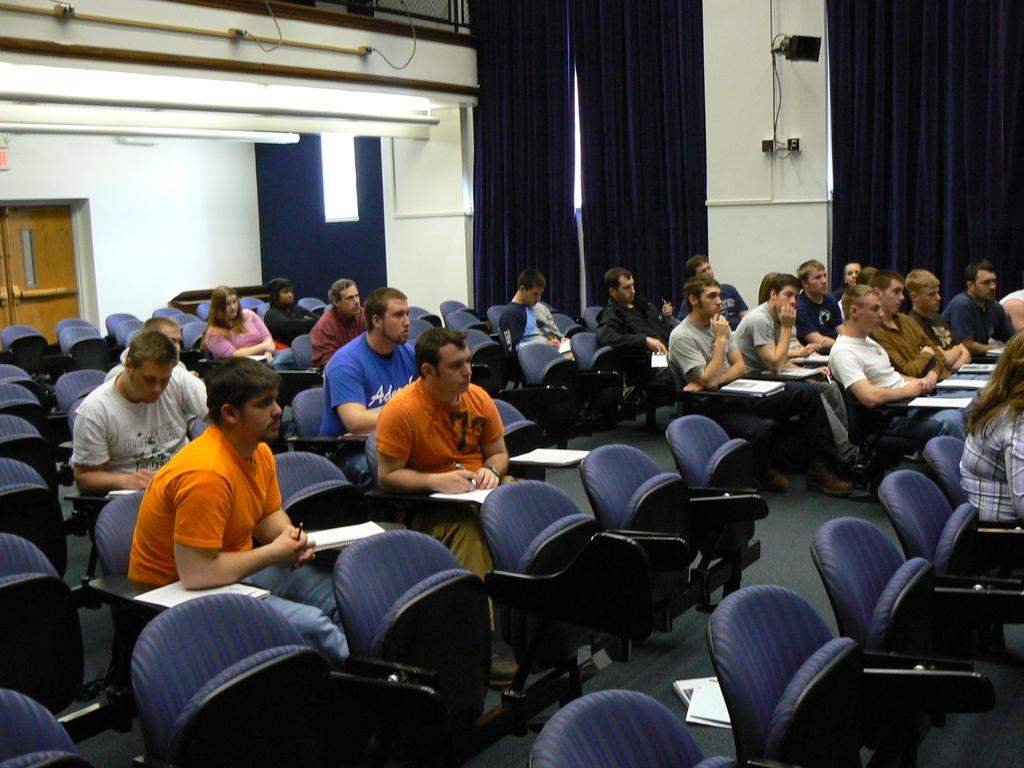How many people are in the image? There are people in the image, but the exact number is not specified in the facts. What are the people doing in the image? The people are sitting on chairs in the image. What might the people be working on or looking at? There are papers in front of the people, so they might be working on or looking at those papers. What type of architectural features can be seen in the image? Walls are visible in the image, and there are also curtains present. Can you describe any objects in the image? Yes, there are objects in the image, but their specific nature is not mentioned in the facts. What type of cushion is on the stove in the image? There is no cushion or stove present in the image. 